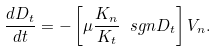<formula> <loc_0><loc_0><loc_500><loc_500>\frac { d D _ { t } } { d t } = - \left [ \mu \frac { K _ { n } } { K _ { t } } \ s g n D _ { t } \right ] V _ { n } .</formula> 